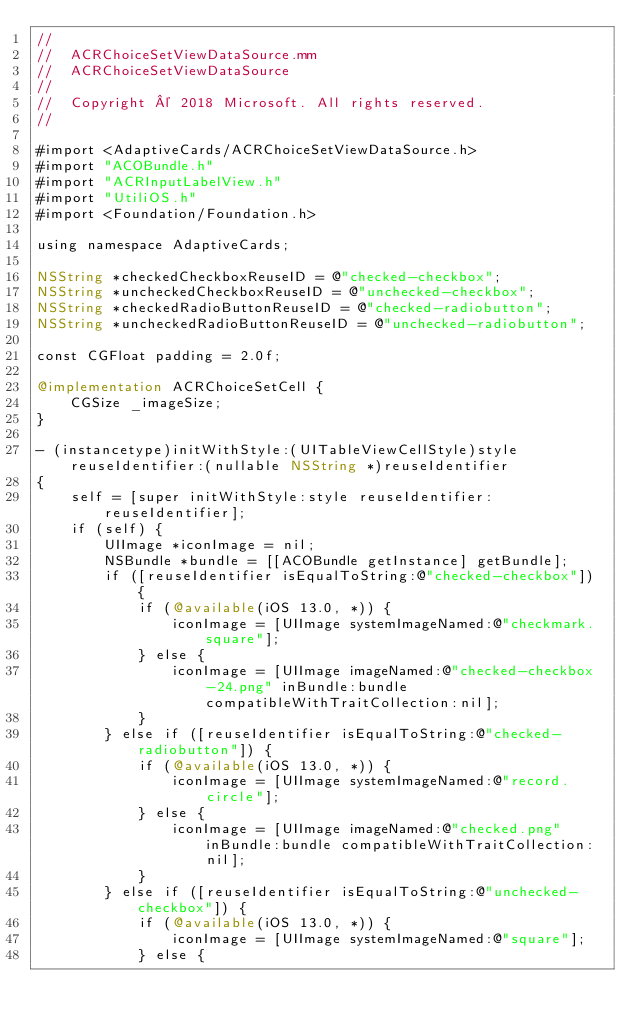Convert code to text. <code><loc_0><loc_0><loc_500><loc_500><_ObjectiveC_>//
//  ACRChoiceSetViewDataSource.mm
//  ACRChoiceSetViewDataSource
//
//  Copyright © 2018 Microsoft. All rights reserved.
//

#import <AdaptiveCards/ACRChoiceSetViewDataSource.h>
#import "ACOBundle.h"
#import "ACRInputLabelView.h"
#import "UtiliOS.h"
#import <Foundation/Foundation.h>

using namespace AdaptiveCards;

NSString *checkedCheckboxReuseID = @"checked-checkbox";
NSString *uncheckedCheckboxReuseID = @"unchecked-checkbox";
NSString *checkedRadioButtonReuseID = @"checked-radiobutton";
NSString *uncheckedRadioButtonReuseID = @"unchecked-radiobutton";

const CGFloat padding = 2.0f;

@implementation ACRChoiceSetCell {
    CGSize _imageSize;
}

- (instancetype)initWithStyle:(UITableViewCellStyle)style reuseIdentifier:(nullable NSString *)reuseIdentifier
{
    self = [super initWithStyle:style reuseIdentifier:reuseIdentifier];
    if (self) {
        UIImage *iconImage = nil;
        NSBundle *bundle = [[ACOBundle getInstance] getBundle];
        if ([reuseIdentifier isEqualToString:@"checked-checkbox"]) {
            if (@available(iOS 13.0, *)) {
                iconImage = [UIImage systemImageNamed:@"checkmark.square"];
            } else {
                iconImage = [UIImage imageNamed:@"checked-checkbox-24.png" inBundle:bundle compatibleWithTraitCollection:nil];
            }
        } else if ([reuseIdentifier isEqualToString:@"checked-radiobutton"]) {
            if (@available(iOS 13.0, *)) {
                iconImage = [UIImage systemImageNamed:@"record.circle"];
            } else {
                iconImage = [UIImage imageNamed:@"checked.png" inBundle:bundle compatibleWithTraitCollection:nil];
            }
        } else if ([reuseIdentifier isEqualToString:@"unchecked-checkbox"]) {
            if (@available(iOS 13.0, *)) {
                iconImage = [UIImage systemImageNamed:@"square"];
            } else {</code> 